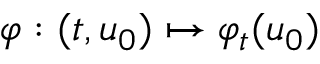Convert formula to latex. <formula><loc_0><loc_0><loc_500><loc_500>\varphi \colon ( t , u _ { 0 } ) \mapsto \varphi _ { t } ( u _ { 0 } )</formula> 